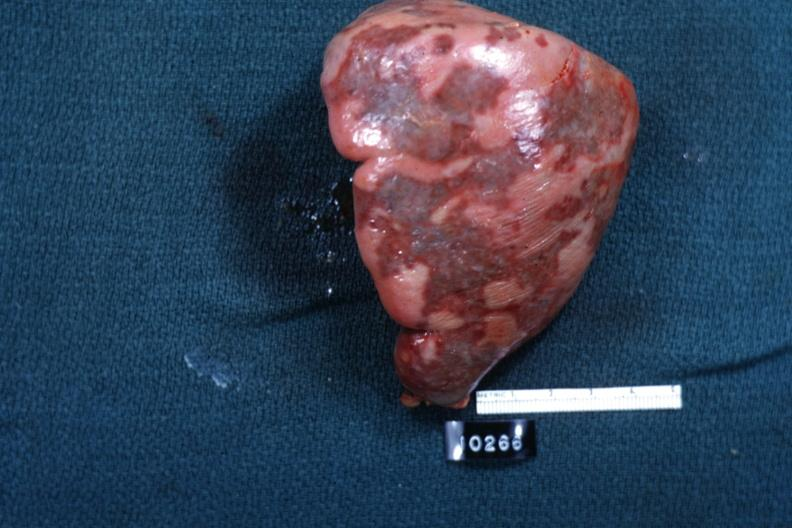s amebiasis present?
Answer the question using a single word or phrase. No 